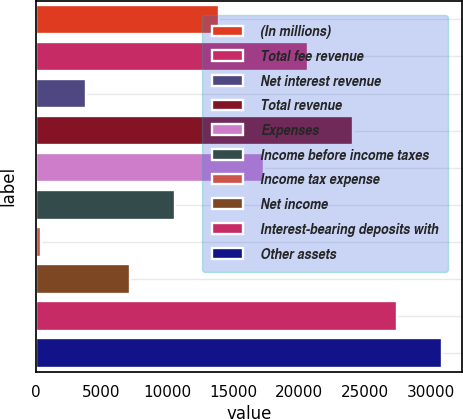Convert chart. <chart><loc_0><loc_0><loc_500><loc_500><bar_chart><fcel>(In millions)<fcel>Total fee revenue<fcel>Net interest revenue<fcel>Total revenue<fcel>Expenses<fcel>Income before income taxes<fcel>Income tax expense<fcel>Net income<fcel>Interest-bearing deposits with<fcel>Other assets<nl><fcel>13941.4<fcel>20704.6<fcel>3796.6<fcel>24086.2<fcel>17323<fcel>10559.8<fcel>415<fcel>7178.2<fcel>27467.8<fcel>30849.4<nl></chart> 